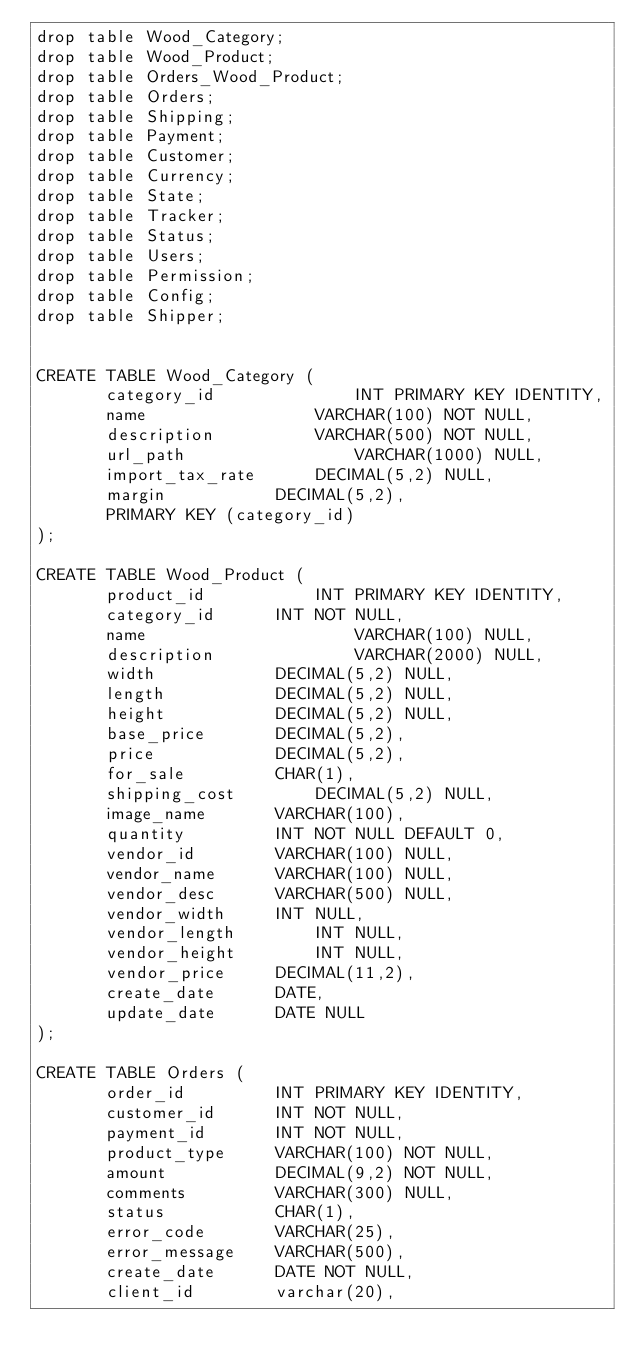Convert code to text. <code><loc_0><loc_0><loc_500><loc_500><_SQL_>drop table Wood_Category;
drop table Wood_Product;
drop table Orders_Wood_Product;
drop table Orders;
drop table Shipping;
drop table Payment;
drop table Customer;
drop table Currency;
drop table State;
drop table Tracker;
drop table Status;
drop table Users;
drop table Permission;
drop table Config;
drop table Shipper;


CREATE TABLE Wood_Category (
       category_id          	INT PRIMARY KEY IDENTITY,
       name          		VARCHAR(100) NOT NULL,
       description     		VARCHAR(500) NOT NULL,
       url_path                	VARCHAR(1000) NULL,
       import_tax_rate		DECIMAL(5,2) NULL,       
       margin			DECIMAL(5,2),
       PRIMARY KEY (category_id)
);

CREATE TABLE Wood_Product (
       product_id          	INT PRIMARY KEY IDENTITY,
       category_id		INT NOT NULL,
       name                 	VARCHAR(100) NULL,
       description             	VARCHAR(2000) NULL,
       width			DECIMAL(5,2) NULL,
       length			DECIMAL(5,2) NULL,
       height			DECIMAL(5,2) NULL,
       base_price		DECIMAL(5,2),
       price			DECIMAL(5,2),
       for_sale			CHAR(1),
       shipping_cost		DECIMAL(5,2) NULL,
       image_name		VARCHAR(100),
       quantity			INT NOT NULL DEFAULT 0,
       vendor_id		VARCHAR(100) NULL,
       vendor_name		VARCHAR(100) NULL,
       vendor_desc		VARCHAR(500) NULL,
       vendor_width		INT NULL,
       vendor_length		INT NULL,
       vendor_height		INT NULL,
       vendor_price		DECIMAL(11,2),
       create_date		DATE,
       update_date		DATE NULL
);

CREATE TABLE Orders (
       order_id         INT PRIMARY KEY IDENTITY,
       customer_id		INT NOT NULL,
       payment_id		INT NOT NULL,
       product_type     VARCHAR(100) NOT NULL,
       amount			DECIMAL(9,2) NOT NULL,       
       comments         VARCHAR(300) NULL,
       status			CHAR(1),
       error_code		VARCHAR(25),
       error_message	VARCHAR(500),
       create_date		DATE NOT NULL,
       client_id		varchar(20), </code> 